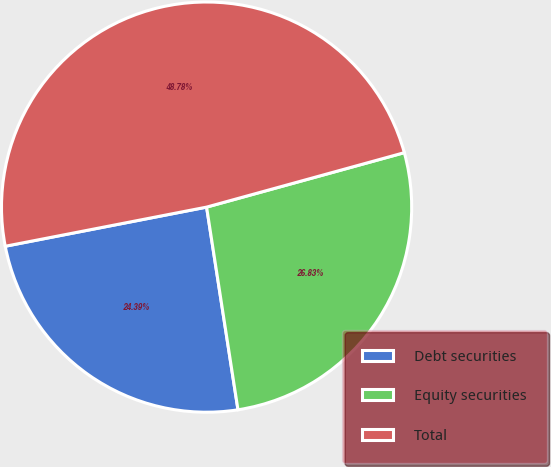Convert chart to OTSL. <chart><loc_0><loc_0><loc_500><loc_500><pie_chart><fcel>Debt securities<fcel>Equity securities<fcel>Total<nl><fcel>24.39%<fcel>26.83%<fcel>48.78%<nl></chart> 